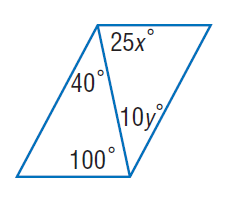Answer the mathemtical geometry problem and directly provide the correct option letter.
Question: Find y so that the quadrilateral is a parallelogram.
Choices: A: 4 B: 8 C: 12 D: 16 A 